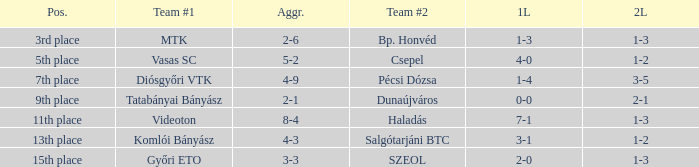What is the 2nd leg of the 4-9 agg.? 3-5. Could you parse the entire table as a dict? {'header': ['Pos.', 'Team #1', 'Aggr.', 'Team #2', '1L', '2L'], 'rows': [['3rd place', 'MTK', '2-6', 'Bp. Honvéd', '1-3', '1-3'], ['5th place', 'Vasas SC', '5-2', 'Csepel', '4-0', '1-2'], ['7th place', 'Diósgyőri VTK', '4-9', 'Pécsi Dózsa', '1-4', '3-5'], ['9th place', 'Tatabányai Bányász', '2-1', 'Dunaújváros', '0-0', '2-1'], ['11th place', 'Videoton', '8-4', 'Haladás', '7-1', '1-3'], ['13th place', 'Komlói Bányász', '4-3', 'Salgótarjáni BTC', '3-1', '1-2'], ['15th place', 'Győri ETO', '3-3', 'SZEOL', '2-0', '1-3']]} 